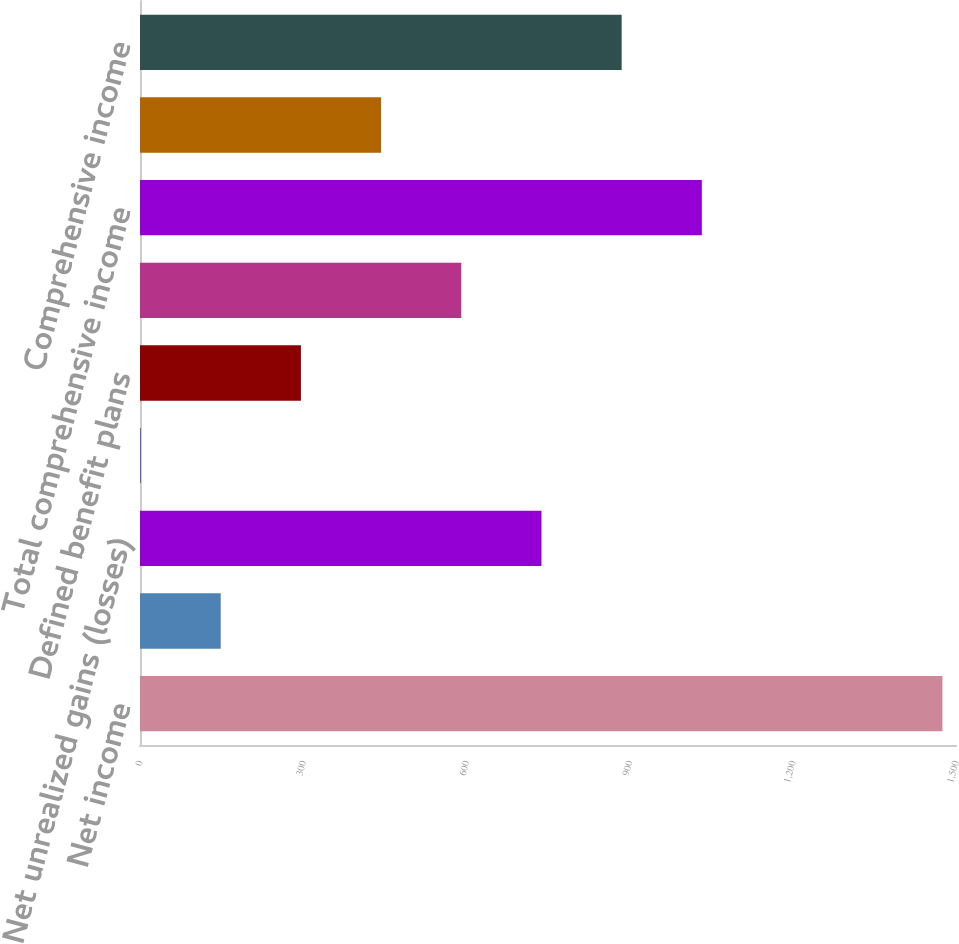<chart> <loc_0><loc_0><loc_500><loc_500><bar_chart><fcel>Net income<fcel>Foreign currency translation<fcel>Net unrealized gains (losses)<fcel>Net unrealized gains on<fcel>Defined benefit plans<fcel>Total other comprehensive<fcel>Total comprehensive income<fcel>Less Comprehensive income<fcel>Comprehensive income<nl><fcel>1475<fcel>148.4<fcel>738<fcel>1<fcel>295.8<fcel>590.6<fcel>1032.8<fcel>443.2<fcel>885.4<nl></chart> 